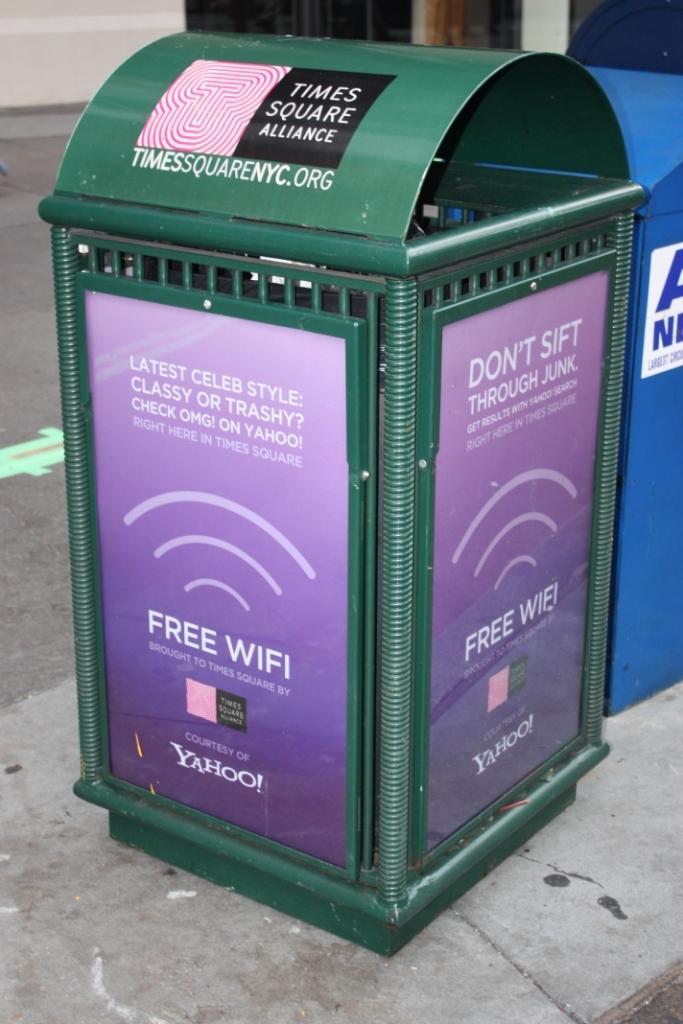<image>
Write a terse but informative summary of the picture. A trash bin on a sidewalk that has an advertisement for free wifi on it. 